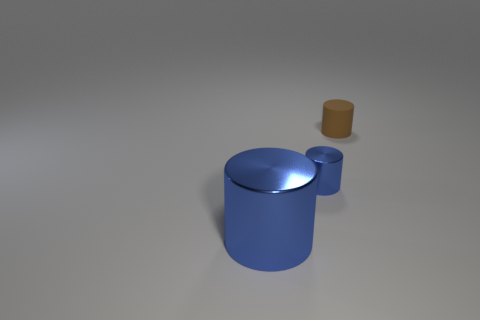Subtract all brown cylinders. Subtract all green cubes. How many cylinders are left? 2 Add 2 blue rubber cylinders. How many objects exist? 5 Subtract 0 cyan spheres. How many objects are left? 3 Subtract all big gray shiny blocks. Subtract all large metal cylinders. How many objects are left? 2 Add 3 rubber cylinders. How many rubber cylinders are left? 4 Add 1 blue metal things. How many blue metal things exist? 3 